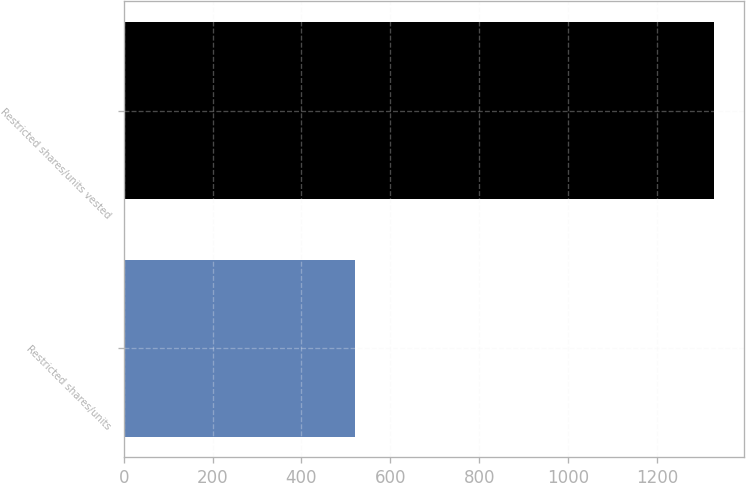<chart> <loc_0><loc_0><loc_500><loc_500><bar_chart><fcel>Restricted shares/units<fcel>Restricted shares/units vested<nl><fcel>521<fcel>1329<nl></chart> 